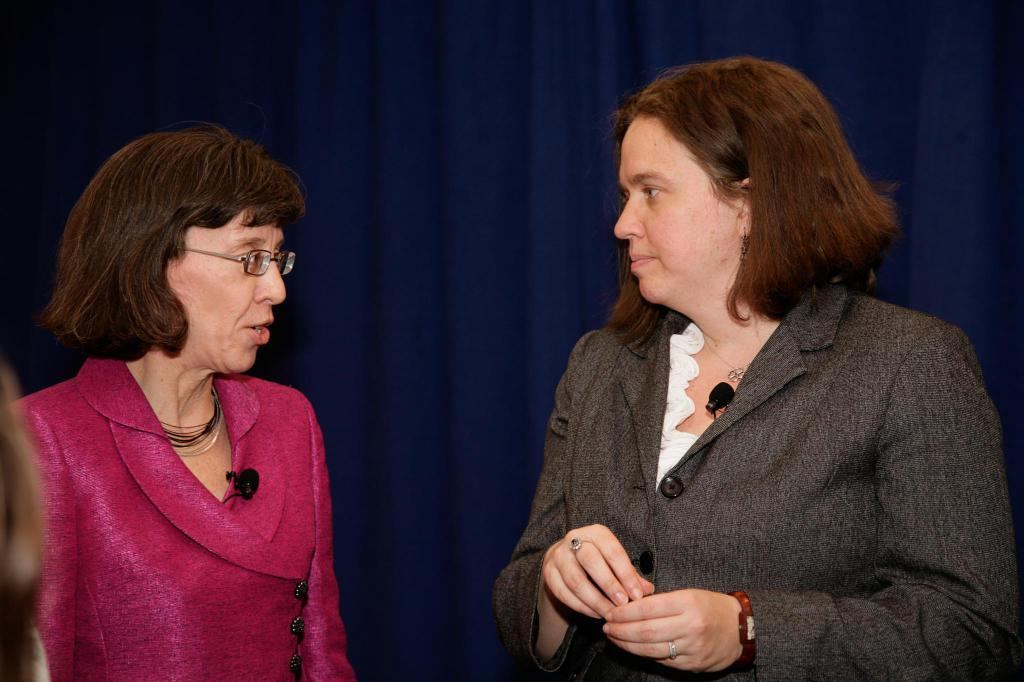How many people are in the image? There are two persons in the image. What can be seen attached to the clothes of the persons? The persons have microphones attached to their clothes. What color is the background in the image? The background in the image is blue. What type of dirt can be seen on the jeans of the persons in the image? There is no mention of jeans or dirt in the image, so it cannot be determined if there is any dirt on the persons' clothing. 